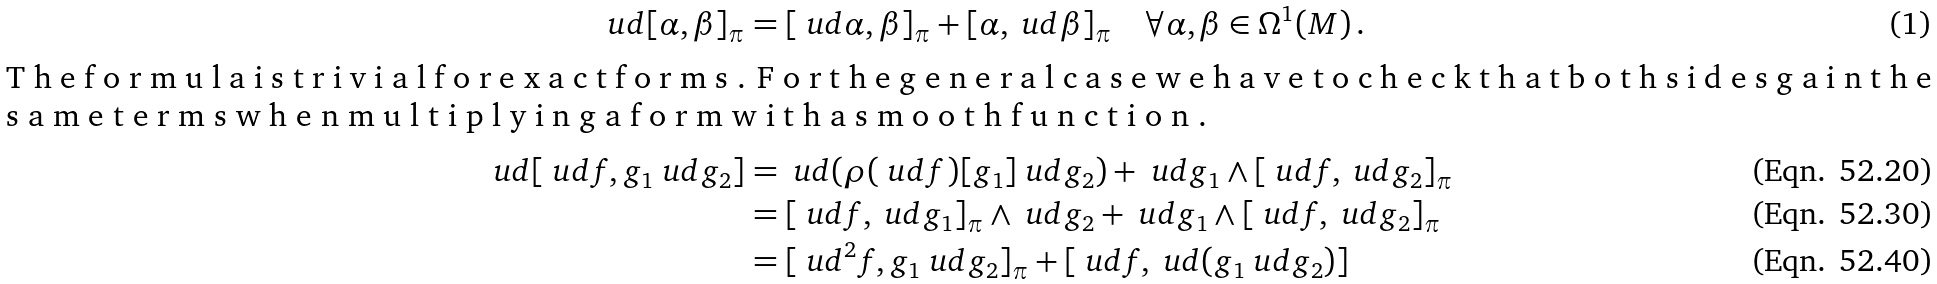<formula> <loc_0><loc_0><loc_500><loc_500>\ u d [ \alpha , \beta ] _ { \pi } & = [ \ u d \alpha , \beta ] _ { \pi } + [ \alpha , \ u d \beta ] _ { \pi } \quad \forall \alpha , \beta \in \Omega ^ { 1 } ( M ) \, . \intertext { T h e f o r m u l a i s t r i v i a l f o r e x a c t f o r m s . F o r t h e g e n e r a l c a s e w e h a v e t o c h e c k t h a t b o t h s i d e s g a i n t h e s a m e t e r m s w h e n m u l t i p l y i n g a f o r m w i t h a s m o o t h f u n c t i o n . } \ u d [ \ u d f , g _ { 1 } \ u d g _ { 2 } ] & = \ u d ( \rho ( \ u d f ) [ g _ { 1 } ] \ u d g _ { 2 } ) + \ u d g _ { 1 } \wedge [ \ u d f , \ u d g _ { 2 } ] _ { \pi } \\ & = [ \ u d f , \ u d g _ { 1 } ] _ { \pi } \wedge \ u d g _ { 2 } + \ u d g _ { 1 } \wedge [ \ u d f , \ u d g _ { 2 } ] _ { \pi } \\ & = [ \ u d ^ { 2 } f , g _ { 1 } \ u d g _ { 2 } ] _ { \pi } + [ \ u d f , \ u d ( g _ { 1 } \ u d g _ { 2 } ) ]</formula> 